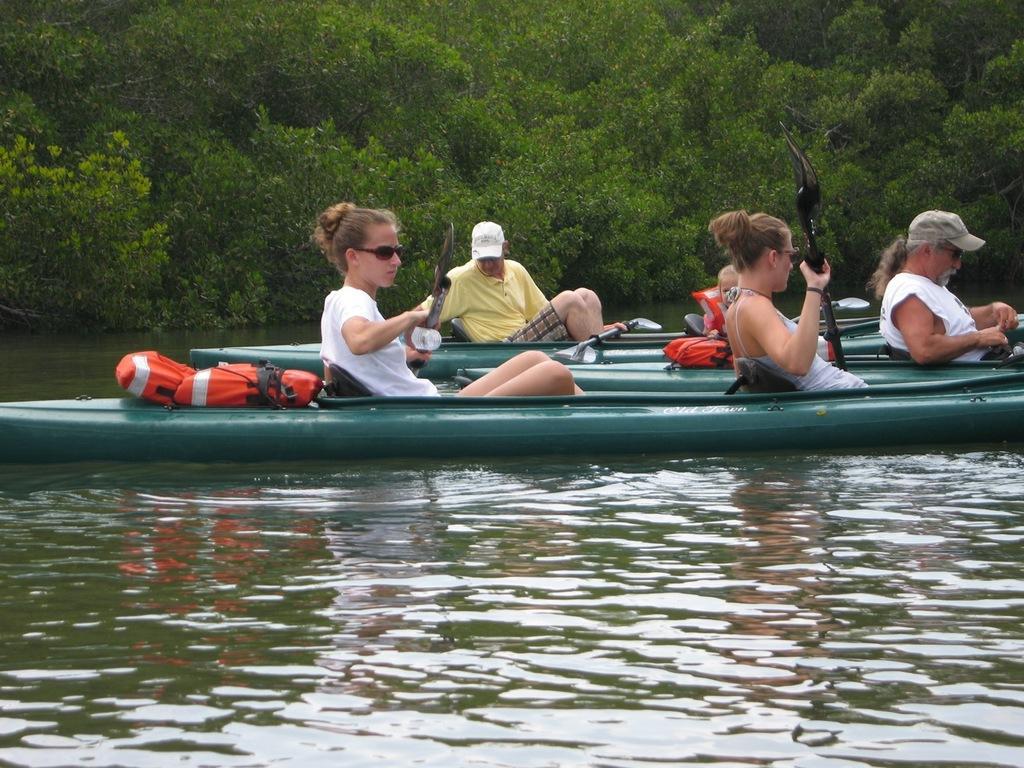Could you give a brief overview of what you see in this image? In the center of the image we can see persons on boat sailing on the water. In the background there are trees. 